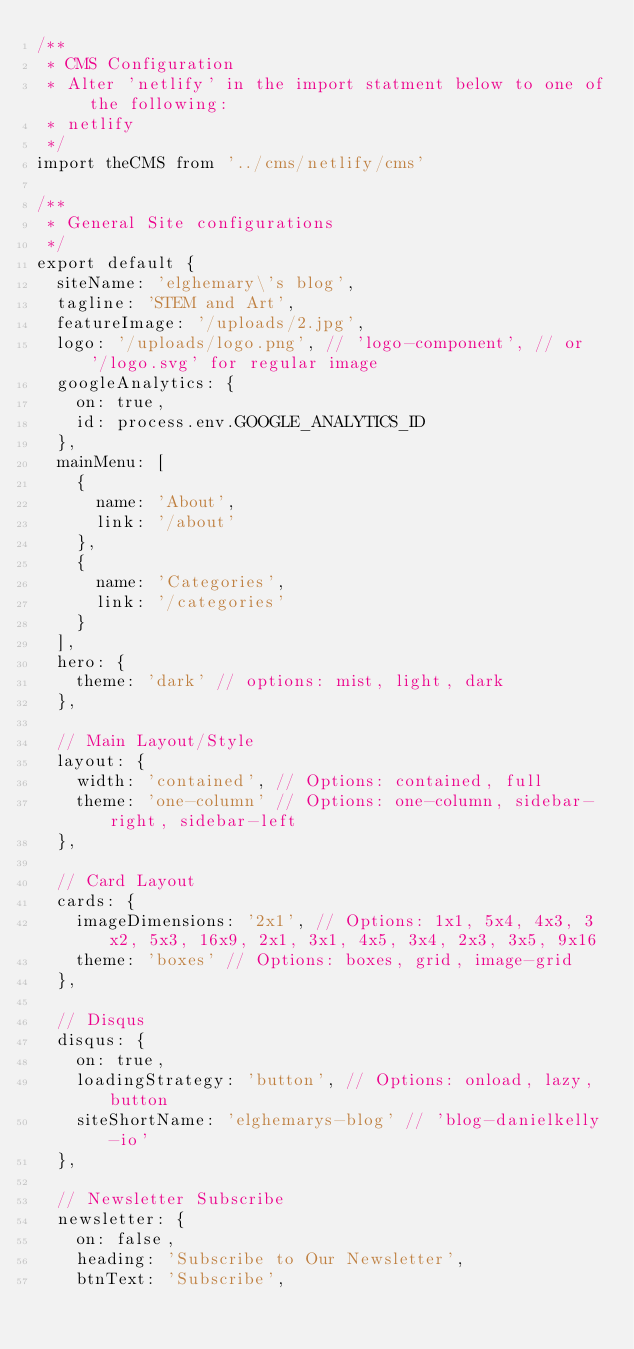<code> <loc_0><loc_0><loc_500><loc_500><_JavaScript_>/**
 * CMS Configuration
 * Alter 'netlify' in the import statment below to one of the following:
 * netlify
 */
import theCMS from '../cms/netlify/cms'

/**
 * General Site configurations
 */
export default {
  siteName: 'elghemary\'s blog',
  tagline: 'STEM and Art',
  featureImage: '/uploads/2.jpg',
  logo: '/uploads/logo.png', // 'logo-component', // or '/logo.svg' for regular image
  googleAnalytics: {
    on: true,
    id: process.env.GOOGLE_ANALYTICS_ID
  },
  mainMenu: [
    {
      name: 'About',
      link: '/about'
    },
    {
      name: 'Categories',
      link: '/categories'
    }
  ],
  hero: {
    theme: 'dark' // options: mist, light, dark
  },

  // Main Layout/Style
  layout: {
    width: 'contained', // Options: contained, full
    theme: 'one-column' // Options: one-column, sidebar-right, sidebar-left
  },

  // Card Layout
  cards: {
    imageDimensions: '2x1', // Options: 1x1, 5x4, 4x3, 3x2, 5x3, 16x9, 2x1, 3x1, 4x5, 3x4, 2x3, 3x5, 9x16
    theme: 'boxes' // Options: boxes, grid, image-grid
  },

  // Disqus
  disqus: {
    on: true,
    loadingStrategy: 'button', // Options: onload, lazy, button
    siteShortName: 'elghemarys-blog' // 'blog-danielkelly-io'
  },

  // Newsletter Subscribe
  newsletter: {
    on: false,
    heading: 'Subscribe to Our Newsletter',
    btnText: 'Subscribe',</code> 